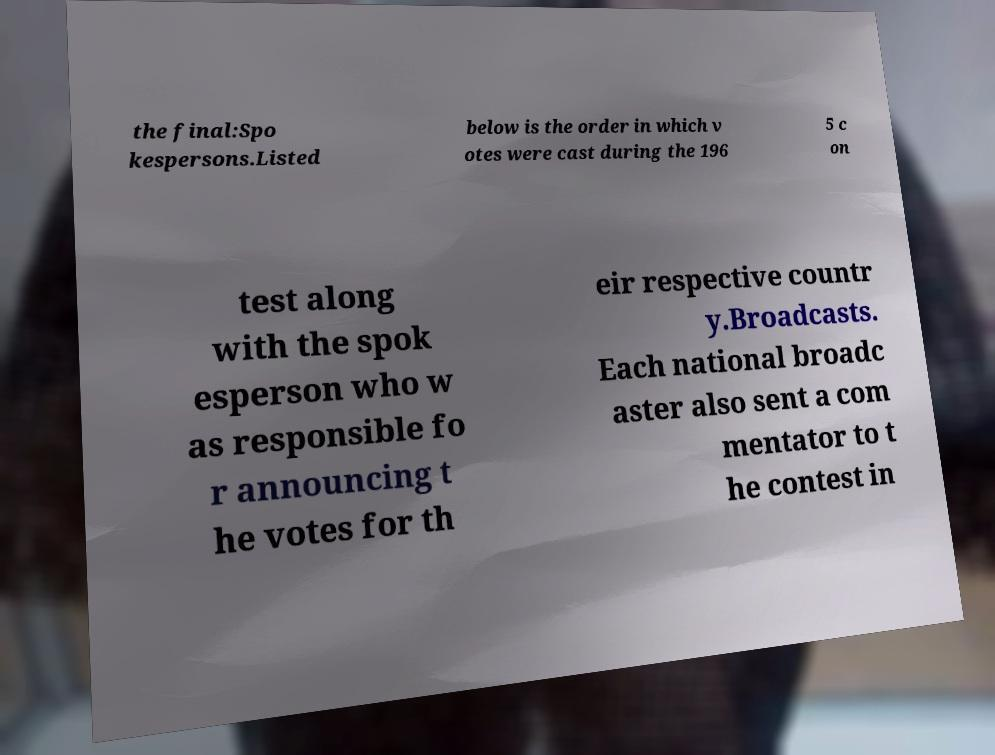Could you extract and type out the text from this image? the final:Spo kespersons.Listed below is the order in which v otes were cast during the 196 5 c on test along with the spok esperson who w as responsible fo r announcing t he votes for th eir respective countr y.Broadcasts. Each national broadc aster also sent a com mentator to t he contest in 